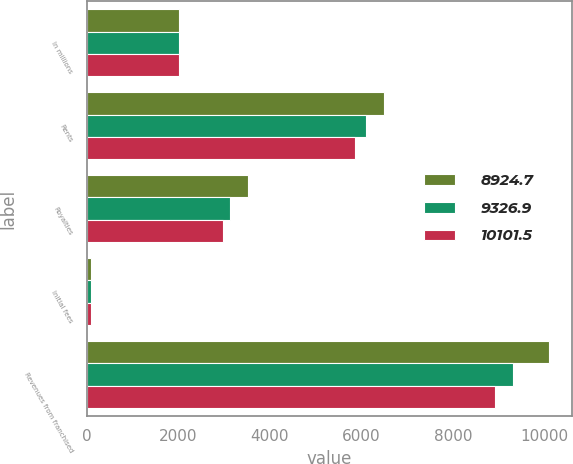<chart> <loc_0><loc_0><loc_500><loc_500><stacked_bar_chart><ecel><fcel>In millions<fcel>Rents<fcel>Royalties<fcel>Initial fees<fcel>Revenues from franchised<nl><fcel>8924.7<fcel>2017<fcel>6496.3<fcel>3518.7<fcel>86.5<fcel>10101.5<nl><fcel>9326.9<fcel>2016<fcel>6107.6<fcel>3129.9<fcel>89.4<fcel>9326.9<nl><fcel>10101.5<fcel>2015<fcel>5860.6<fcel>2980.7<fcel>83.4<fcel>8924.7<nl></chart> 